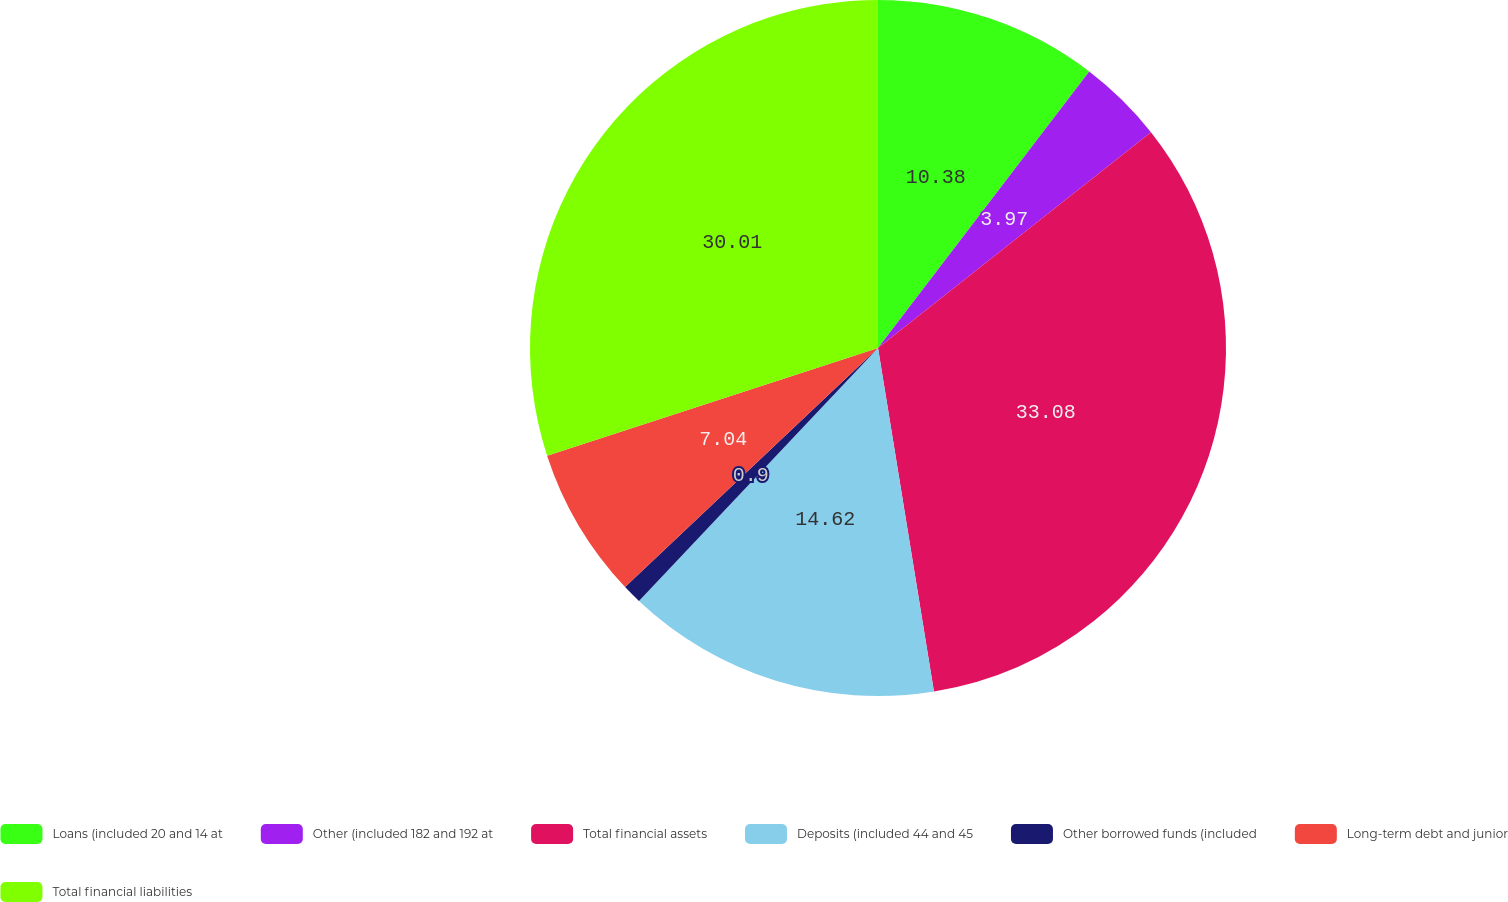Convert chart to OTSL. <chart><loc_0><loc_0><loc_500><loc_500><pie_chart><fcel>Loans (included 20 and 14 at<fcel>Other (included 182 and 192 at<fcel>Total financial assets<fcel>Deposits (included 44 and 45<fcel>Other borrowed funds (included<fcel>Long-term debt and junior<fcel>Total financial liabilities<nl><fcel>10.38%<fcel>3.97%<fcel>33.08%<fcel>14.62%<fcel>0.9%<fcel>7.04%<fcel>30.01%<nl></chart> 